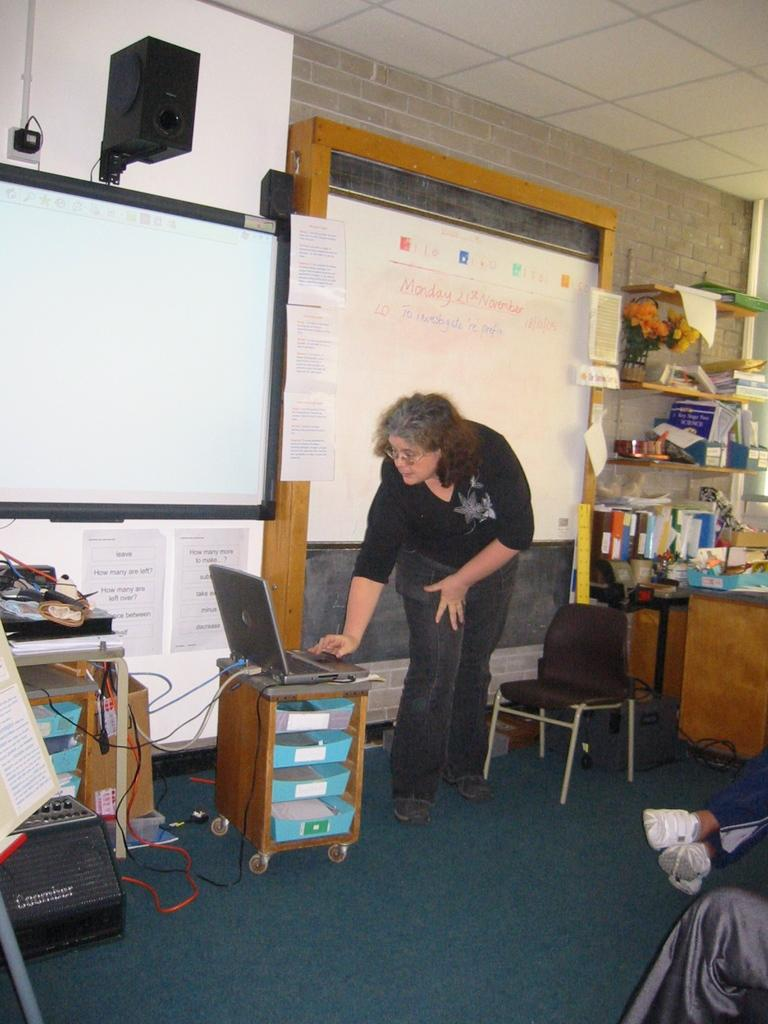What is the primary subject in the image? There is a woman standing in the image. What object is on the table in the image? There is a laptop on a table in the image. What piece of furniture is present in the image? There is a chair in the image. What type of objects are present on the boards in the image? The boards in the image have items on them. What is the purpose of the rack in the image? There are items in a rack in the image, which suggests it is used for storage or display. Whose leg is visible in the image? A person's leg is visible in the image, but it is not specified whose leg it is. What type of soup is being prepared in the image? There is no soup present in the image, nor any indication of cooking or food preparation. 